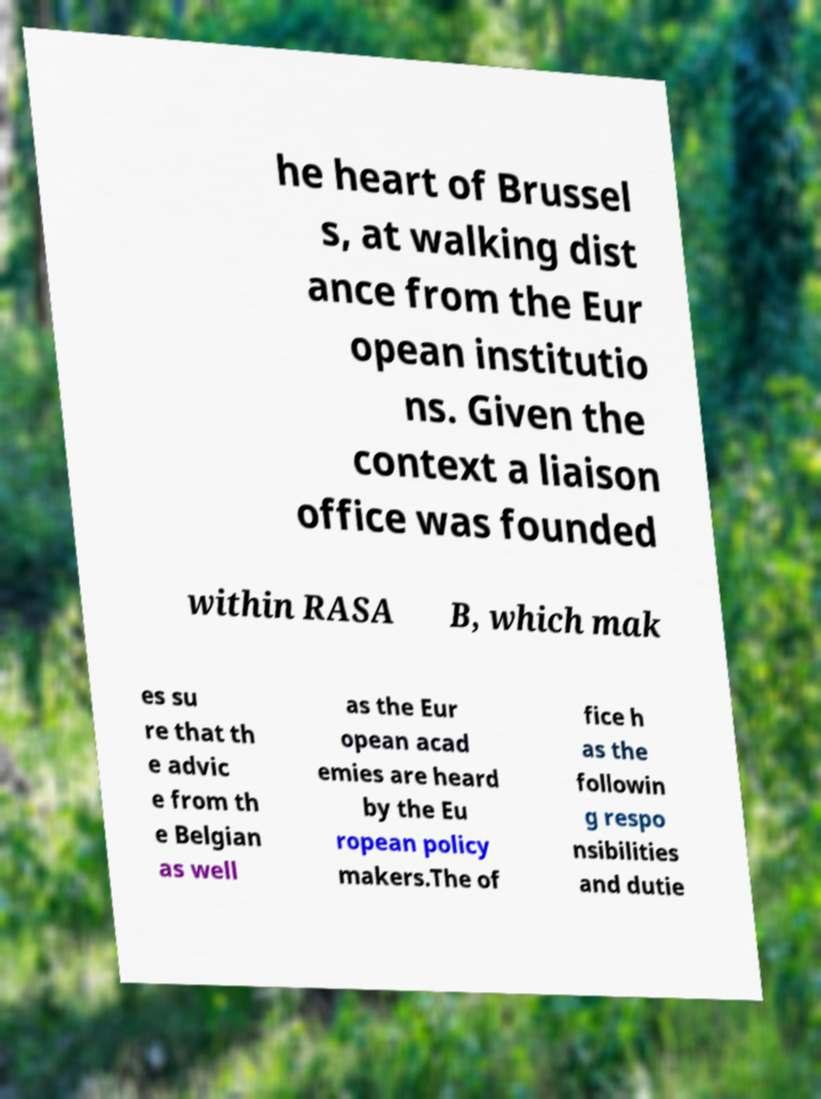Can you read and provide the text displayed in the image?This photo seems to have some interesting text. Can you extract and type it out for me? he heart of Brussel s, at walking dist ance from the Eur opean institutio ns. Given the context a liaison office was founded within RASA B, which mak es su re that th e advic e from th e Belgian as well as the Eur opean acad emies are heard by the Eu ropean policy makers.The of fice h as the followin g respo nsibilities and dutie 